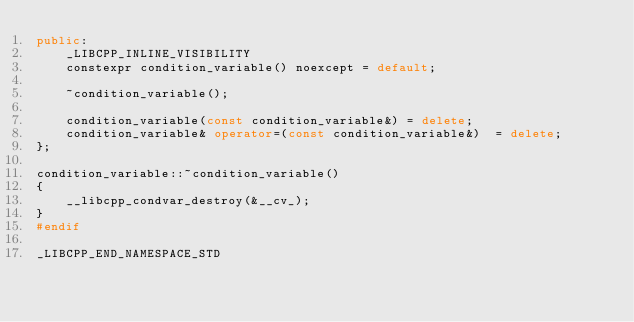<code> <loc_0><loc_0><loc_500><loc_500><_C++_>public:
    _LIBCPP_INLINE_VISIBILITY
    constexpr condition_variable() noexcept = default;

    ~condition_variable();

    condition_variable(const condition_variable&) = delete;
    condition_variable& operator=(const condition_variable&)  = delete;
};

condition_variable::~condition_variable()
{
    __libcpp_condvar_destroy(&__cv_);
}
#endif

_LIBCPP_END_NAMESPACE_STD
</code> 